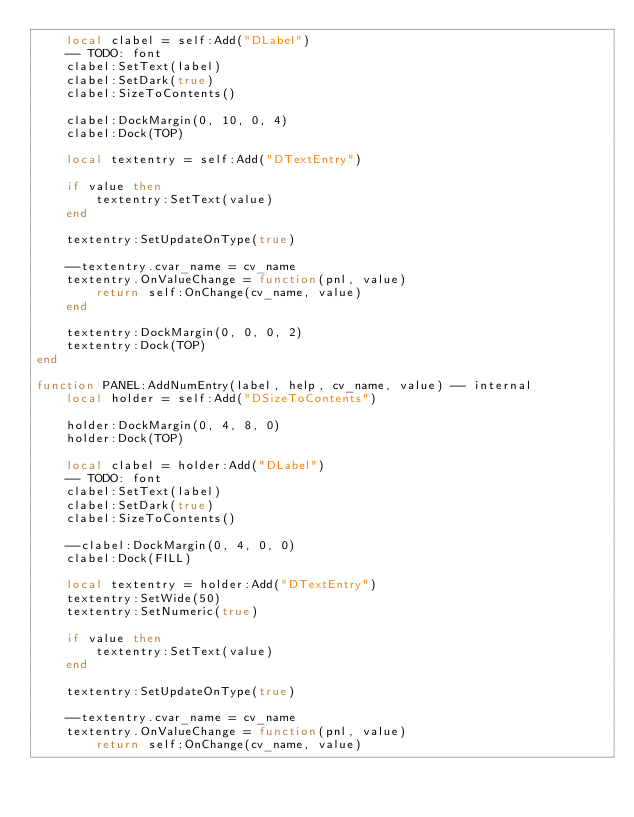Convert code to text. <code><loc_0><loc_0><loc_500><loc_500><_Lua_>	local clabel = self:Add("DLabel")
	-- TODO: font
	clabel:SetText(label)
	clabel:SetDark(true)
	clabel:SizeToContents()
	
	clabel:DockMargin(0, 10, 0, 4)
	clabel:Dock(TOP)
	
	local textentry = self:Add("DTextEntry")
	
	if value then
		textentry:SetText(value)
	end
	
	textentry:SetUpdateOnType(true)
	
	--textentry.cvar_name = cv_name
	textentry.OnValueChange = function(pnl, value)
		return self:OnChange(cv_name, value)
	end
	
	textentry:DockMargin(0, 0, 0, 2)
	textentry:Dock(TOP)
end

function PANEL:AddNumEntry(label, help, cv_name, value) -- internal
	local holder = self:Add("DSizeToContents")
	
	holder:DockMargin(0, 4, 8, 0)
	holder:Dock(TOP)
	
	local clabel = holder:Add("DLabel")
	-- TODO: font
	clabel:SetText(label)
	clabel:SetDark(true)
	clabel:SizeToContents()
	
	--clabel:DockMargin(0, 4, 0, 0)
	clabel:Dock(FILL)
	
	local textentry = holder:Add("DTextEntry")
	textentry:SetWide(50)
	textentry:SetNumeric(true)
	
	if value then
		textentry:SetText(value)
	end
	
	textentry:SetUpdateOnType(true)
	
	--textentry.cvar_name = cv_name
	textentry.OnValueChange = function(pnl, value)
		return self:OnChange(cv_name, value)</code> 